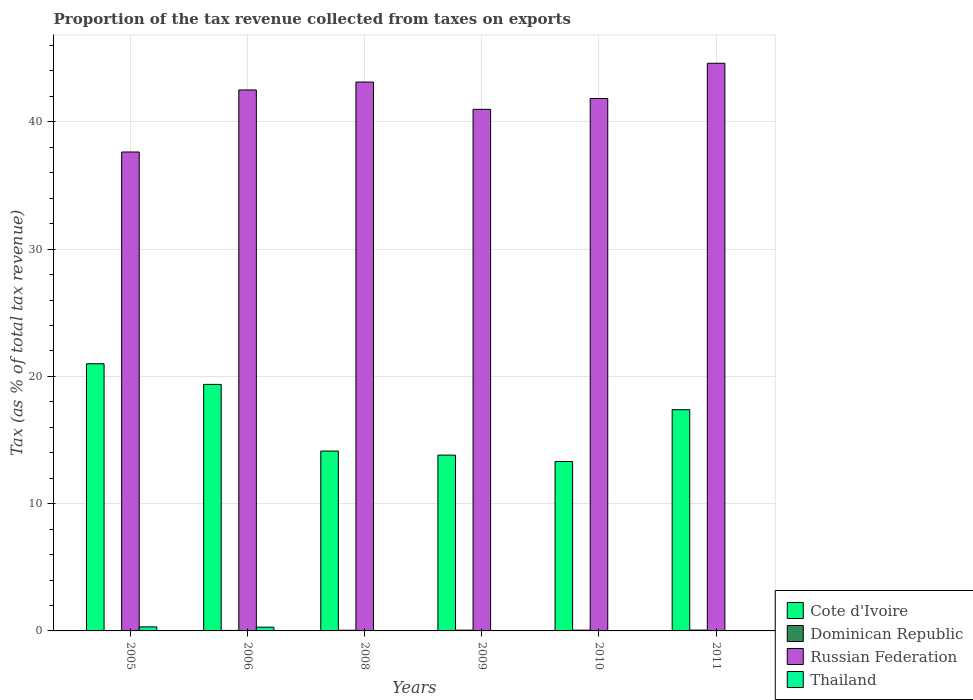How many groups of bars are there?
Ensure brevity in your answer.  6. How many bars are there on the 6th tick from the right?
Make the answer very short. 4. In how many cases, is the number of bars for a given year not equal to the number of legend labels?
Your answer should be compact. 0. What is the proportion of the tax revenue collected in Cote d'Ivoire in 2010?
Keep it short and to the point. 13.31. Across all years, what is the maximum proportion of the tax revenue collected in Thailand?
Ensure brevity in your answer.  0.32. Across all years, what is the minimum proportion of the tax revenue collected in Russian Federation?
Your response must be concise. 37.63. In which year was the proportion of the tax revenue collected in Dominican Republic minimum?
Your answer should be compact. 2005. What is the total proportion of the tax revenue collected in Dominican Republic in the graph?
Keep it short and to the point. 0.29. What is the difference between the proportion of the tax revenue collected in Russian Federation in 2005 and that in 2008?
Make the answer very short. -5.5. What is the difference between the proportion of the tax revenue collected in Dominican Republic in 2011 and the proportion of the tax revenue collected in Russian Federation in 2005?
Offer a terse response. -37.57. What is the average proportion of the tax revenue collected in Dominican Republic per year?
Keep it short and to the point. 0.05. In the year 2008, what is the difference between the proportion of the tax revenue collected in Cote d'Ivoire and proportion of the tax revenue collected in Russian Federation?
Give a very brief answer. -29. What is the ratio of the proportion of the tax revenue collected in Thailand in 2010 to that in 2011?
Your answer should be very brief. 0.8. Is the proportion of the tax revenue collected in Russian Federation in 2008 less than that in 2009?
Offer a terse response. No. Is the difference between the proportion of the tax revenue collected in Cote d'Ivoire in 2005 and 2010 greater than the difference between the proportion of the tax revenue collected in Russian Federation in 2005 and 2010?
Give a very brief answer. Yes. What is the difference between the highest and the second highest proportion of the tax revenue collected in Dominican Republic?
Ensure brevity in your answer.  0.01. What is the difference between the highest and the lowest proportion of the tax revenue collected in Russian Federation?
Make the answer very short. 6.97. Is it the case that in every year, the sum of the proportion of the tax revenue collected in Dominican Republic and proportion of the tax revenue collected in Cote d'Ivoire is greater than the sum of proportion of the tax revenue collected in Russian Federation and proportion of the tax revenue collected in Thailand?
Provide a succinct answer. No. What does the 3rd bar from the left in 2010 represents?
Ensure brevity in your answer.  Russian Federation. What does the 4th bar from the right in 2010 represents?
Offer a terse response. Cote d'Ivoire. Are all the bars in the graph horizontal?
Provide a succinct answer. No. Are the values on the major ticks of Y-axis written in scientific E-notation?
Your answer should be very brief. No. How many legend labels are there?
Offer a very short reply. 4. What is the title of the graph?
Keep it short and to the point. Proportion of the tax revenue collected from taxes on exports. Does "Bulgaria" appear as one of the legend labels in the graph?
Ensure brevity in your answer.  No. What is the label or title of the Y-axis?
Provide a short and direct response. Tax (as % of total tax revenue). What is the Tax (as % of total tax revenue) in Cote d'Ivoire in 2005?
Your answer should be compact. 21. What is the Tax (as % of total tax revenue) in Dominican Republic in 2005?
Offer a terse response. 0.01. What is the Tax (as % of total tax revenue) of Russian Federation in 2005?
Provide a short and direct response. 37.63. What is the Tax (as % of total tax revenue) in Thailand in 2005?
Provide a short and direct response. 0.32. What is the Tax (as % of total tax revenue) in Cote d'Ivoire in 2006?
Keep it short and to the point. 19.37. What is the Tax (as % of total tax revenue) in Dominican Republic in 2006?
Offer a terse response. 0.04. What is the Tax (as % of total tax revenue) in Russian Federation in 2006?
Offer a terse response. 42.51. What is the Tax (as % of total tax revenue) of Thailand in 2006?
Your answer should be very brief. 0.3. What is the Tax (as % of total tax revenue) of Cote d'Ivoire in 2008?
Make the answer very short. 14.13. What is the Tax (as % of total tax revenue) in Dominican Republic in 2008?
Keep it short and to the point. 0.05. What is the Tax (as % of total tax revenue) in Russian Federation in 2008?
Offer a very short reply. 43.13. What is the Tax (as % of total tax revenue) of Thailand in 2008?
Your answer should be very brief. 0.03. What is the Tax (as % of total tax revenue) in Cote d'Ivoire in 2009?
Give a very brief answer. 13.81. What is the Tax (as % of total tax revenue) of Dominican Republic in 2009?
Offer a very short reply. 0.06. What is the Tax (as % of total tax revenue) in Russian Federation in 2009?
Offer a very short reply. 40.99. What is the Tax (as % of total tax revenue) of Thailand in 2009?
Your answer should be compact. 0.03. What is the Tax (as % of total tax revenue) of Cote d'Ivoire in 2010?
Offer a terse response. 13.31. What is the Tax (as % of total tax revenue) of Dominican Republic in 2010?
Ensure brevity in your answer.  0.06. What is the Tax (as % of total tax revenue) of Russian Federation in 2010?
Your answer should be compact. 41.84. What is the Tax (as % of total tax revenue) in Thailand in 2010?
Your answer should be compact. 0.01. What is the Tax (as % of total tax revenue) of Cote d'Ivoire in 2011?
Your answer should be compact. 17.38. What is the Tax (as % of total tax revenue) of Dominican Republic in 2011?
Your answer should be very brief. 0.07. What is the Tax (as % of total tax revenue) in Russian Federation in 2011?
Offer a terse response. 44.61. What is the Tax (as % of total tax revenue) in Thailand in 2011?
Give a very brief answer. 0.01. Across all years, what is the maximum Tax (as % of total tax revenue) of Cote d'Ivoire?
Keep it short and to the point. 21. Across all years, what is the maximum Tax (as % of total tax revenue) in Dominican Republic?
Provide a succinct answer. 0.07. Across all years, what is the maximum Tax (as % of total tax revenue) of Russian Federation?
Offer a terse response. 44.61. Across all years, what is the maximum Tax (as % of total tax revenue) in Thailand?
Offer a terse response. 0.32. Across all years, what is the minimum Tax (as % of total tax revenue) in Cote d'Ivoire?
Keep it short and to the point. 13.31. Across all years, what is the minimum Tax (as % of total tax revenue) of Dominican Republic?
Give a very brief answer. 0.01. Across all years, what is the minimum Tax (as % of total tax revenue) of Russian Federation?
Keep it short and to the point. 37.63. Across all years, what is the minimum Tax (as % of total tax revenue) in Thailand?
Provide a short and direct response. 0.01. What is the total Tax (as % of total tax revenue) in Cote d'Ivoire in the graph?
Give a very brief answer. 99.01. What is the total Tax (as % of total tax revenue) in Dominican Republic in the graph?
Your answer should be compact. 0.29. What is the total Tax (as % of total tax revenue) of Russian Federation in the graph?
Offer a terse response. 250.71. What is the total Tax (as % of total tax revenue) of Thailand in the graph?
Provide a succinct answer. 0.7. What is the difference between the Tax (as % of total tax revenue) in Cote d'Ivoire in 2005 and that in 2006?
Your answer should be very brief. 1.62. What is the difference between the Tax (as % of total tax revenue) in Dominican Republic in 2005 and that in 2006?
Offer a very short reply. -0.03. What is the difference between the Tax (as % of total tax revenue) in Russian Federation in 2005 and that in 2006?
Your response must be concise. -4.87. What is the difference between the Tax (as % of total tax revenue) of Thailand in 2005 and that in 2006?
Your response must be concise. 0.02. What is the difference between the Tax (as % of total tax revenue) in Cote d'Ivoire in 2005 and that in 2008?
Keep it short and to the point. 6.86. What is the difference between the Tax (as % of total tax revenue) in Dominican Republic in 2005 and that in 2008?
Offer a very short reply. -0.05. What is the difference between the Tax (as % of total tax revenue) in Russian Federation in 2005 and that in 2008?
Provide a succinct answer. -5.5. What is the difference between the Tax (as % of total tax revenue) of Thailand in 2005 and that in 2008?
Your answer should be compact. 0.28. What is the difference between the Tax (as % of total tax revenue) of Cote d'Ivoire in 2005 and that in 2009?
Provide a short and direct response. 7.18. What is the difference between the Tax (as % of total tax revenue) in Dominican Republic in 2005 and that in 2009?
Provide a succinct answer. -0.05. What is the difference between the Tax (as % of total tax revenue) in Russian Federation in 2005 and that in 2009?
Offer a terse response. -3.35. What is the difference between the Tax (as % of total tax revenue) in Thailand in 2005 and that in 2009?
Your response must be concise. 0.29. What is the difference between the Tax (as % of total tax revenue) of Cote d'Ivoire in 2005 and that in 2010?
Give a very brief answer. 7.69. What is the difference between the Tax (as % of total tax revenue) in Dominican Republic in 2005 and that in 2010?
Provide a succinct answer. -0.05. What is the difference between the Tax (as % of total tax revenue) in Russian Federation in 2005 and that in 2010?
Provide a succinct answer. -4.2. What is the difference between the Tax (as % of total tax revenue) in Thailand in 2005 and that in 2010?
Keep it short and to the point. 0.31. What is the difference between the Tax (as % of total tax revenue) in Cote d'Ivoire in 2005 and that in 2011?
Your answer should be very brief. 3.61. What is the difference between the Tax (as % of total tax revenue) in Dominican Republic in 2005 and that in 2011?
Provide a short and direct response. -0.06. What is the difference between the Tax (as % of total tax revenue) in Russian Federation in 2005 and that in 2011?
Keep it short and to the point. -6.97. What is the difference between the Tax (as % of total tax revenue) in Thailand in 2005 and that in 2011?
Your answer should be very brief. 0.3. What is the difference between the Tax (as % of total tax revenue) in Cote d'Ivoire in 2006 and that in 2008?
Offer a terse response. 5.24. What is the difference between the Tax (as % of total tax revenue) in Dominican Republic in 2006 and that in 2008?
Your answer should be very brief. -0.02. What is the difference between the Tax (as % of total tax revenue) in Russian Federation in 2006 and that in 2008?
Your response must be concise. -0.62. What is the difference between the Tax (as % of total tax revenue) of Thailand in 2006 and that in 2008?
Offer a very short reply. 0.26. What is the difference between the Tax (as % of total tax revenue) in Cote d'Ivoire in 2006 and that in 2009?
Your response must be concise. 5.56. What is the difference between the Tax (as % of total tax revenue) in Dominican Republic in 2006 and that in 2009?
Your answer should be compact. -0.02. What is the difference between the Tax (as % of total tax revenue) in Russian Federation in 2006 and that in 2009?
Make the answer very short. 1.52. What is the difference between the Tax (as % of total tax revenue) in Thailand in 2006 and that in 2009?
Make the answer very short. 0.27. What is the difference between the Tax (as % of total tax revenue) in Cote d'Ivoire in 2006 and that in 2010?
Provide a short and direct response. 6.06. What is the difference between the Tax (as % of total tax revenue) in Dominican Republic in 2006 and that in 2010?
Your answer should be compact. -0.02. What is the difference between the Tax (as % of total tax revenue) of Russian Federation in 2006 and that in 2010?
Your answer should be compact. 0.67. What is the difference between the Tax (as % of total tax revenue) of Thailand in 2006 and that in 2010?
Offer a very short reply. 0.28. What is the difference between the Tax (as % of total tax revenue) of Cote d'Ivoire in 2006 and that in 2011?
Your answer should be compact. 1.99. What is the difference between the Tax (as % of total tax revenue) of Dominican Republic in 2006 and that in 2011?
Provide a short and direct response. -0.03. What is the difference between the Tax (as % of total tax revenue) in Russian Federation in 2006 and that in 2011?
Keep it short and to the point. -2.1. What is the difference between the Tax (as % of total tax revenue) in Thailand in 2006 and that in 2011?
Make the answer very short. 0.28. What is the difference between the Tax (as % of total tax revenue) of Cote d'Ivoire in 2008 and that in 2009?
Your response must be concise. 0.32. What is the difference between the Tax (as % of total tax revenue) in Dominican Republic in 2008 and that in 2009?
Give a very brief answer. -0.01. What is the difference between the Tax (as % of total tax revenue) of Russian Federation in 2008 and that in 2009?
Make the answer very short. 2.15. What is the difference between the Tax (as % of total tax revenue) of Thailand in 2008 and that in 2009?
Ensure brevity in your answer.  0. What is the difference between the Tax (as % of total tax revenue) of Cote d'Ivoire in 2008 and that in 2010?
Provide a short and direct response. 0.82. What is the difference between the Tax (as % of total tax revenue) of Dominican Republic in 2008 and that in 2010?
Offer a very short reply. -0.01. What is the difference between the Tax (as % of total tax revenue) in Russian Federation in 2008 and that in 2010?
Your answer should be compact. 1.3. What is the difference between the Tax (as % of total tax revenue) in Thailand in 2008 and that in 2010?
Make the answer very short. 0.02. What is the difference between the Tax (as % of total tax revenue) in Cote d'Ivoire in 2008 and that in 2011?
Give a very brief answer. -3.25. What is the difference between the Tax (as % of total tax revenue) of Dominican Republic in 2008 and that in 2011?
Offer a very short reply. -0.01. What is the difference between the Tax (as % of total tax revenue) of Russian Federation in 2008 and that in 2011?
Provide a short and direct response. -1.48. What is the difference between the Tax (as % of total tax revenue) of Thailand in 2008 and that in 2011?
Offer a very short reply. 0.02. What is the difference between the Tax (as % of total tax revenue) of Cote d'Ivoire in 2009 and that in 2010?
Make the answer very short. 0.5. What is the difference between the Tax (as % of total tax revenue) in Dominican Republic in 2009 and that in 2010?
Provide a short and direct response. -0. What is the difference between the Tax (as % of total tax revenue) of Russian Federation in 2009 and that in 2010?
Your answer should be compact. -0.85. What is the difference between the Tax (as % of total tax revenue) of Thailand in 2009 and that in 2010?
Give a very brief answer. 0.02. What is the difference between the Tax (as % of total tax revenue) in Cote d'Ivoire in 2009 and that in 2011?
Make the answer very short. -3.57. What is the difference between the Tax (as % of total tax revenue) of Dominican Republic in 2009 and that in 2011?
Offer a very short reply. -0.01. What is the difference between the Tax (as % of total tax revenue) in Russian Federation in 2009 and that in 2011?
Make the answer very short. -3.62. What is the difference between the Tax (as % of total tax revenue) of Thailand in 2009 and that in 2011?
Your answer should be compact. 0.02. What is the difference between the Tax (as % of total tax revenue) of Cote d'Ivoire in 2010 and that in 2011?
Provide a succinct answer. -4.07. What is the difference between the Tax (as % of total tax revenue) of Dominican Republic in 2010 and that in 2011?
Ensure brevity in your answer.  -0.01. What is the difference between the Tax (as % of total tax revenue) in Russian Federation in 2010 and that in 2011?
Make the answer very short. -2.77. What is the difference between the Tax (as % of total tax revenue) of Thailand in 2010 and that in 2011?
Make the answer very short. -0. What is the difference between the Tax (as % of total tax revenue) in Cote d'Ivoire in 2005 and the Tax (as % of total tax revenue) in Dominican Republic in 2006?
Your answer should be compact. 20.96. What is the difference between the Tax (as % of total tax revenue) in Cote d'Ivoire in 2005 and the Tax (as % of total tax revenue) in Russian Federation in 2006?
Your answer should be compact. -21.51. What is the difference between the Tax (as % of total tax revenue) of Cote d'Ivoire in 2005 and the Tax (as % of total tax revenue) of Thailand in 2006?
Keep it short and to the point. 20.7. What is the difference between the Tax (as % of total tax revenue) in Dominican Republic in 2005 and the Tax (as % of total tax revenue) in Russian Federation in 2006?
Offer a very short reply. -42.5. What is the difference between the Tax (as % of total tax revenue) of Dominican Republic in 2005 and the Tax (as % of total tax revenue) of Thailand in 2006?
Offer a very short reply. -0.29. What is the difference between the Tax (as % of total tax revenue) of Russian Federation in 2005 and the Tax (as % of total tax revenue) of Thailand in 2006?
Your response must be concise. 37.34. What is the difference between the Tax (as % of total tax revenue) of Cote d'Ivoire in 2005 and the Tax (as % of total tax revenue) of Dominican Republic in 2008?
Make the answer very short. 20.94. What is the difference between the Tax (as % of total tax revenue) of Cote d'Ivoire in 2005 and the Tax (as % of total tax revenue) of Russian Federation in 2008?
Provide a short and direct response. -22.14. What is the difference between the Tax (as % of total tax revenue) of Cote d'Ivoire in 2005 and the Tax (as % of total tax revenue) of Thailand in 2008?
Offer a terse response. 20.96. What is the difference between the Tax (as % of total tax revenue) in Dominican Republic in 2005 and the Tax (as % of total tax revenue) in Russian Federation in 2008?
Ensure brevity in your answer.  -43.12. What is the difference between the Tax (as % of total tax revenue) in Dominican Republic in 2005 and the Tax (as % of total tax revenue) in Thailand in 2008?
Provide a succinct answer. -0.02. What is the difference between the Tax (as % of total tax revenue) of Russian Federation in 2005 and the Tax (as % of total tax revenue) of Thailand in 2008?
Ensure brevity in your answer.  37.6. What is the difference between the Tax (as % of total tax revenue) of Cote d'Ivoire in 2005 and the Tax (as % of total tax revenue) of Dominican Republic in 2009?
Provide a short and direct response. 20.94. What is the difference between the Tax (as % of total tax revenue) in Cote d'Ivoire in 2005 and the Tax (as % of total tax revenue) in Russian Federation in 2009?
Offer a terse response. -19.99. What is the difference between the Tax (as % of total tax revenue) in Cote d'Ivoire in 2005 and the Tax (as % of total tax revenue) in Thailand in 2009?
Your answer should be very brief. 20.97. What is the difference between the Tax (as % of total tax revenue) in Dominican Republic in 2005 and the Tax (as % of total tax revenue) in Russian Federation in 2009?
Your response must be concise. -40.98. What is the difference between the Tax (as % of total tax revenue) in Dominican Republic in 2005 and the Tax (as % of total tax revenue) in Thailand in 2009?
Keep it short and to the point. -0.02. What is the difference between the Tax (as % of total tax revenue) in Russian Federation in 2005 and the Tax (as % of total tax revenue) in Thailand in 2009?
Offer a very short reply. 37.61. What is the difference between the Tax (as % of total tax revenue) of Cote d'Ivoire in 2005 and the Tax (as % of total tax revenue) of Dominican Republic in 2010?
Ensure brevity in your answer.  20.94. What is the difference between the Tax (as % of total tax revenue) of Cote d'Ivoire in 2005 and the Tax (as % of total tax revenue) of Russian Federation in 2010?
Keep it short and to the point. -20.84. What is the difference between the Tax (as % of total tax revenue) of Cote d'Ivoire in 2005 and the Tax (as % of total tax revenue) of Thailand in 2010?
Keep it short and to the point. 20.99. What is the difference between the Tax (as % of total tax revenue) in Dominican Republic in 2005 and the Tax (as % of total tax revenue) in Russian Federation in 2010?
Provide a succinct answer. -41.83. What is the difference between the Tax (as % of total tax revenue) of Dominican Republic in 2005 and the Tax (as % of total tax revenue) of Thailand in 2010?
Keep it short and to the point. -0. What is the difference between the Tax (as % of total tax revenue) in Russian Federation in 2005 and the Tax (as % of total tax revenue) in Thailand in 2010?
Give a very brief answer. 37.62. What is the difference between the Tax (as % of total tax revenue) in Cote d'Ivoire in 2005 and the Tax (as % of total tax revenue) in Dominican Republic in 2011?
Your answer should be very brief. 20.93. What is the difference between the Tax (as % of total tax revenue) of Cote d'Ivoire in 2005 and the Tax (as % of total tax revenue) of Russian Federation in 2011?
Give a very brief answer. -23.61. What is the difference between the Tax (as % of total tax revenue) of Cote d'Ivoire in 2005 and the Tax (as % of total tax revenue) of Thailand in 2011?
Offer a terse response. 20.98. What is the difference between the Tax (as % of total tax revenue) of Dominican Republic in 2005 and the Tax (as % of total tax revenue) of Russian Federation in 2011?
Provide a succinct answer. -44.6. What is the difference between the Tax (as % of total tax revenue) of Dominican Republic in 2005 and the Tax (as % of total tax revenue) of Thailand in 2011?
Give a very brief answer. -0. What is the difference between the Tax (as % of total tax revenue) in Russian Federation in 2005 and the Tax (as % of total tax revenue) in Thailand in 2011?
Offer a very short reply. 37.62. What is the difference between the Tax (as % of total tax revenue) of Cote d'Ivoire in 2006 and the Tax (as % of total tax revenue) of Dominican Republic in 2008?
Offer a very short reply. 19.32. What is the difference between the Tax (as % of total tax revenue) of Cote d'Ivoire in 2006 and the Tax (as % of total tax revenue) of Russian Federation in 2008?
Provide a succinct answer. -23.76. What is the difference between the Tax (as % of total tax revenue) of Cote d'Ivoire in 2006 and the Tax (as % of total tax revenue) of Thailand in 2008?
Make the answer very short. 19.34. What is the difference between the Tax (as % of total tax revenue) of Dominican Republic in 2006 and the Tax (as % of total tax revenue) of Russian Federation in 2008?
Your answer should be compact. -43.09. What is the difference between the Tax (as % of total tax revenue) in Dominican Republic in 2006 and the Tax (as % of total tax revenue) in Thailand in 2008?
Offer a very short reply. 0.01. What is the difference between the Tax (as % of total tax revenue) of Russian Federation in 2006 and the Tax (as % of total tax revenue) of Thailand in 2008?
Make the answer very short. 42.48. What is the difference between the Tax (as % of total tax revenue) of Cote d'Ivoire in 2006 and the Tax (as % of total tax revenue) of Dominican Republic in 2009?
Make the answer very short. 19.31. What is the difference between the Tax (as % of total tax revenue) of Cote d'Ivoire in 2006 and the Tax (as % of total tax revenue) of Russian Federation in 2009?
Offer a very short reply. -21.61. What is the difference between the Tax (as % of total tax revenue) of Cote d'Ivoire in 2006 and the Tax (as % of total tax revenue) of Thailand in 2009?
Provide a short and direct response. 19.34. What is the difference between the Tax (as % of total tax revenue) of Dominican Republic in 2006 and the Tax (as % of total tax revenue) of Russian Federation in 2009?
Provide a short and direct response. -40.95. What is the difference between the Tax (as % of total tax revenue) of Dominican Republic in 2006 and the Tax (as % of total tax revenue) of Thailand in 2009?
Provide a short and direct response. 0.01. What is the difference between the Tax (as % of total tax revenue) of Russian Federation in 2006 and the Tax (as % of total tax revenue) of Thailand in 2009?
Make the answer very short. 42.48. What is the difference between the Tax (as % of total tax revenue) in Cote d'Ivoire in 2006 and the Tax (as % of total tax revenue) in Dominican Republic in 2010?
Your answer should be compact. 19.31. What is the difference between the Tax (as % of total tax revenue) in Cote d'Ivoire in 2006 and the Tax (as % of total tax revenue) in Russian Federation in 2010?
Provide a short and direct response. -22.46. What is the difference between the Tax (as % of total tax revenue) in Cote d'Ivoire in 2006 and the Tax (as % of total tax revenue) in Thailand in 2010?
Your response must be concise. 19.36. What is the difference between the Tax (as % of total tax revenue) in Dominican Republic in 2006 and the Tax (as % of total tax revenue) in Russian Federation in 2010?
Your response must be concise. -41.8. What is the difference between the Tax (as % of total tax revenue) of Dominican Republic in 2006 and the Tax (as % of total tax revenue) of Thailand in 2010?
Your answer should be very brief. 0.03. What is the difference between the Tax (as % of total tax revenue) of Russian Federation in 2006 and the Tax (as % of total tax revenue) of Thailand in 2010?
Offer a terse response. 42.5. What is the difference between the Tax (as % of total tax revenue) of Cote d'Ivoire in 2006 and the Tax (as % of total tax revenue) of Dominican Republic in 2011?
Give a very brief answer. 19.31. What is the difference between the Tax (as % of total tax revenue) in Cote d'Ivoire in 2006 and the Tax (as % of total tax revenue) in Russian Federation in 2011?
Provide a succinct answer. -25.24. What is the difference between the Tax (as % of total tax revenue) in Cote d'Ivoire in 2006 and the Tax (as % of total tax revenue) in Thailand in 2011?
Your answer should be compact. 19.36. What is the difference between the Tax (as % of total tax revenue) in Dominican Republic in 2006 and the Tax (as % of total tax revenue) in Russian Federation in 2011?
Keep it short and to the point. -44.57. What is the difference between the Tax (as % of total tax revenue) of Dominican Republic in 2006 and the Tax (as % of total tax revenue) of Thailand in 2011?
Keep it short and to the point. 0.03. What is the difference between the Tax (as % of total tax revenue) in Russian Federation in 2006 and the Tax (as % of total tax revenue) in Thailand in 2011?
Your response must be concise. 42.5. What is the difference between the Tax (as % of total tax revenue) in Cote d'Ivoire in 2008 and the Tax (as % of total tax revenue) in Dominican Republic in 2009?
Give a very brief answer. 14.07. What is the difference between the Tax (as % of total tax revenue) in Cote d'Ivoire in 2008 and the Tax (as % of total tax revenue) in Russian Federation in 2009?
Give a very brief answer. -26.85. What is the difference between the Tax (as % of total tax revenue) of Cote d'Ivoire in 2008 and the Tax (as % of total tax revenue) of Thailand in 2009?
Provide a succinct answer. 14.1. What is the difference between the Tax (as % of total tax revenue) of Dominican Republic in 2008 and the Tax (as % of total tax revenue) of Russian Federation in 2009?
Your answer should be very brief. -40.93. What is the difference between the Tax (as % of total tax revenue) in Dominican Republic in 2008 and the Tax (as % of total tax revenue) in Thailand in 2009?
Offer a terse response. 0.03. What is the difference between the Tax (as % of total tax revenue) in Russian Federation in 2008 and the Tax (as % of total tax revenue) in Thailand in 2009?
Give a very brief answer. 43.1. What is the difference between the Tax (as % of total tax revenue) in Cote d'Ivoire in 2008 and the Tax (as % of total tax revenue) in Dominican Republic in 2010?
Provide a succinct answer. 14.07. What is the difference between the Tax (as % of total tax revenue) in Cote d'Ivoire in 2008 and the Tax (as % of total tax revenue) in Russian Federation in 2010?
Ensure brevity in your answer.  -27.7. What is the difference between the Tax (as % of total tax revenue) in Cote d'Ivoire in 2008 and the Tax (as % of total tax revenue) in Thailand in 2010?
Your response must be concise. 14.12. What is the difference between the Tax (as % of total tax revenue) of Dominican Republic in 2008 and the Tax (as % of total tax revenue) of Russian Federation in 2010?
Make the answer very short. -41.78. What is the difference between the Tax (as % of total tax revenue) in Dominican Republic in 2008 and the Tax (as % of total tax revenue) in Thailand in 2010?
Your answer should be very brief. 0.04. What is the difference between the Tax (as % of total tax revenue) in Russian Federation in 2008 and the Tax (as % of total tax revenue) in Thailand in 2010?
Ensure brevity in your answer.  43.12. What is the difference between the Tax (as % of total tax revenue) in Cote d'Ivoire in 2008 and the Tax (as % of total tax revenue) in Dominican Republic in 2011?
Offer a terse response. 14.07. What is the difference between the Tax (as % of total tax revenue) of Cote d'Ivoire in 2008 and the Tax (as % of total tax revenue) of Russian Federation in 2011?
Give a very brief answer. -30.47. What is the difference between the Tax (as % of total tax revenue) of Cote d'Ivoire in 2008 and the Tax (as % of total tax revenue) of Thailand in 2011?
Offer a terse response. 14.12. What is the difference between the Tax (as % of total tax revenue) in Dominican Republic in 2008 and the Tax (as % of total tax revenue) in Russian Federation in 2011?
Offer a terse response. -44.55. What is the difference between the Tax (as % of total tax revenue) of Dominican Republic in 2008 and the Tax (as % of total tax revenue) of Thailand in 2011?
Make the answer very short. 0.04. What is the difference between the Tax (as % of total tax revenue) of Russian Federation in 2008 and the Tax (as % of total tax revenue) of Thailand in 2011?
Provide a short and direct response. 43.12. What is the difference between the Tax (as % of total tax revenue) in Cote d'Ivoire in 2009 and the Tax (as % of total tax revenue) in Dominican Republic in 2010?
Keep it short and to the point. 13.75. What is the difference between the Tax (as % of total tax revenue) in Cote d'Ivoire in 2009 and the Tax (as % of total tax revenue) in Russian Federation in 2010?
Offer a terse response. -28.02. What is the difference between the Tax (as % of total tax revenue) in Cote d'Ivoire in 2009 and the Tax (as % of total tax revenue) in Thailand in 2010?
Offer a very short reply. 13.8. What is the difference between the Tax (as % of total tax revenue) in Dominican Republic in 2009 and the Tax (as % of total tax revenue) in Russian Federation in 2010?
Your response must be concise. -41.78. What is the difference between the Tax (as % of total tax revenue) of Dominican Republic in 2009 and the Tax (as % of total tax revenue) of Thailand in 2010?
Your answer should be compact. 0.05. What is the difference between the Tax (as % of total tax revenue) of Russian Federation in 2009 and the Tax (as % of total tax revenue) of Thailand in 2010?
Keep it short and to the point. 40.98. What is the difference between the Tax (as % of total tax revenue) in Cote d'Ivoire in 2009 and the Tax (as % of total tax revenue) in Dominican Republic in 2011?
Keep it short and to the point. 13.75. What is the difference between the Tax (as % of total tax revenue) of Cote d'Ivoire in 2009 and the Tax (as % of total tax revenue) of Russian Federation in 2011?
Make the answer very short. -30.79. What is the difference between the Tax (as % of total tax revenue) of Cote d'Ivoire in 2009 and the Tax (as % of total tax revenue) of Thailand in 2011?
Provide a short and direct response. 13.8. What is the difference between the Tax (as % of total tax revenue) in Dominican Republic in 2009 and the Tax (as % of total tax revenue) in Russian Federation in 2011?
Give a very brief answer. -44.55. What is the difference between the Tax (as % of total tax revenue) in Dominican Republic in 2009 and the Tax (as % of total tax revenue) in Thailand in 2011?
Provide a short and direct response. 0.05. What is the difference between the Tax (as % of total tax revenue) of Russian Federation in 2009 and the Tax (as % of total tax revenue) of Thailand in 2011?
Provide a succinct answer. 40.97. What is the difference between the Tax (as % of total tax revenue) of Cote d'Ivoire in 2010 and the Tax (as % of total tax revenue) of Dominican Republic in 2011?
Your answer should be very brief. 13.24. What is the difference between the Tax (as % of total tax revenue) of Cote d'Ivoire in 2010 and the Tax (as % of total tax revenue) of Russian Federation in 2011?
Offer a terse response. -31.3. What is the difference between the Tax (as % of total tax revenue) in Cote d'Ivoire in 2010 and the Tax (as % of total tax revenue) in Thailand in 2011?
Your answer should be very brief. 13.3. What is the difference between the Tax (as % of total tax revenue) in Dominican Republic in 2010 and the Tax (as % of total tax revenue) in Russian Federation in 2011?
Ensure brevity in your answer.  -44.55. What is the difference between the Tax (as % of total tax revenue) in Dominican Republic in 2010 and the Tax (as % of total tax revenue) in Thailand in 2011?
Provide a succinct answer. 0.05. What is the difference between the Tax (as % of total tax revenue) in Russian Federation in 2010 and the Tax (as % of total tax revenue) in Thailand in 2011?
Give a very brief answer. 41.82. What is the average Tax (as % of total tax revenue) in Cote d'Ivoire per year?
Provide a succinct answer. 16.5. What is the average Tax (as % of total tax revenue) in Dominican Republic per year?
Give a very brief answer. 0.05. What is the average Tax (as % of total tax revenue) in Russian Federation per year?
Give a very brief answer. 41.78. What is the average Tax (as % of total tax revenue) of Thailand per year?
Provide a succinct answer. 0.12. In the year 2005, what is the difference between the Tax (as % of total tax revenue) of Cote d'Ivoire and Tax (as % of total tax revenue) of Dominican Republic?
Your answer should be compact. 20.99. In the year 2005, what is the difference between the Tax (as % of total tax revenue) of Cote d'Ivoire and Tax (as % of total tax revenue) of Russian Federation?
Provide a short and direct response. -16.64. In the year 2005, what is the difference between the Tax (as % of total tax revenue) in Cote d'Ivoire and Tax (as % of total tax revenue) in Thailand?
Your answer should be very brief. 20.68. In the year 2005, what is the difference between the Tax (as % of total tax revenue) of Dominican Republic and Tax (as % of total tax revenue) of Russian Federation?
Ensure brevity in your answer.  -37.63. In the year 2005, what is the difference between the Tax (as % of total tax revenue) of Dominican Republic and Tax (as % of total tax revenue) of Thailand?
Make the answer very short. -0.31. In the year 2005, what is the difference between the Tax (as % of total tax revenue) of Russian Federation and Tax (as % of total tax revenue) of Thailand?
Give a very brief answer. 37.32. In the year 2006, what is the difference between the Tax (as % of total tax revenue) of Cote d'Ivoire and Tax (as % of total tax revenue) of Dominican Republic?
Keep it short and to the point. 19.33. In the year 2006, what is the difference between the Tax (as % of total tax revenue) of Cote d'Ivoire and Tax (as % of total tax revenue) of Russian Federation?
Provide a short and direct response. -23.14. In the year 2006, what is the difference between the Tax (as % of total tax revenue) of Cote d'Ivoire and Tax (as % of total tax revenue) of Thailand?
Give a very brief answer. 19.08. In the year 2006, what is the difference between the Tax (as % of total tax revenue) of Dominican Republic and Tax (as % of total tax revenue) of Russian Federation?
Keep it short and to the point. -42.47. In the year 2006, what is the difference between the Tax (as % of total tax revenue) of Dominican Republic and Tax (as % of total tax revenue) of Thailand?
Your answer should be compact. -0.26. In the year 2006, what is the difference between the Tax (as % of total tax revenue) of Russian Federation and Tax (as % of total tax revenue) of Thailand?
Offer a terse response. 42.21. In the year 2008, what is the difference between the Tax (as % of total tax revenue) in Cote d'Ivoire and Tax (as % of total tax revenue) in Dominican Republic?
Give a very brief answer. 14.08. In the year 2008, what is the difference between the Tax (as % of total tax revenue) of Cote d'Ivoire and Tax (as % of total tax revenue) of Russian Federation?
Make the answer very short. -29. In the year 2008, what is the difference between the Tax (as % of total tax revenue) in Cote d'Ivoire and Tax (as % of total tax revenue) in Thailand?
Your response must be concise. 14.1. In the year 2008, what is the difference between the Tax (as % of total tax revenue) of Dominican Republic and Tax (as % of total tax revenue) of Russian Federation?
Your answer should be compact. -43.08. In the year 2008, what is the difference between the Tax (as % of total tax revenue) of Dominican Republic and Tax (as % of total tax revenue) of Thailand?
Make the answer very short. 0.02. In the year 2008, what is the difference between the Tax (as % of total tax revenue) of Russian Federation and Tax (as % of total tax revenue) of Thailand?
Keep it short and to the point. 43.1. In the year 2009, what is the difference between the Tax (as % of total tax revenue) of Cote d'Ivoire and Tax (as % of total tax revenue) of Dominican Republic?
Keep it short and to the point. 13.75. In the year 2009, what is the difference between the Tax (as % of total tax revenue) of Cote d'Ivoire and Tax (as % of total tax revenue) of Russian Federation?
Provide a short and direct response. -27.17. In the year 2009, what is the difference between the Tax (as % of total tax revenue) in Cote d'Ivoire and Tax (as % of total tax revenue) in Thailand?
Provide a short and direct response. 13.79. In the year 2009, what is the difference between the Tax (as % of total tax revenue) of Dominican Republic and Tax (as % of total tax revenue) of Russian Federation?
Your answer should be compact. -40.93. In the year 2009, what is the difference between the Tax (as % of total tax revenue) of Dominican Republic and Tax (as % of total tax revenue) of Thailand?
Your answer should be very brief. 0.03. In the year 2009, what is the difference between the Tax (as % of total tax revenue) of Russian Federation and Tax (as % of total tax revenue) of Thailand?
Your answer should be compact. 40.96. In the year 2010, what is the difference between the Tax (as % of total tax revenue) in Cote d'Ivoire and Tax (as % of total tax revenue) in Dominican Republic?
Your answer should be compact. 13.25. In the year 2010, what is the difference between the Tax (as % of total tax revenue) in Cote d'Ivoire and Tax (as % of total tax revenue) in Russian Federation?
Keep it short and to the point. -28.53. In the year 2010, what is the difference between the Tax (as % of total tax revenue) of Cote d'Ivoire and Tax (as % of total tax revenue) of Thailand?
Offer a very short reply. 13.3. In the year 2010, what is the difference between the Tax (as % of total tax revenue) of Dominican Republic and Tax (as % of total tax revenue) of Russian Federation?
Your response must be concise. -41.78. In the year 2010, what is the difference between the Tax (as % of total tax revenue) in Dominican Republic and Tax (as % of total tax revenue) in Thailand?
Provide a succinct answer. 0.05. In the year 2010, what is the difference between the Tax (as % of total tax revenue) in Russian Federation and Tax (as % of total tax revenue) in Thailand?
Your response must be concise. 41.83. In the year 2011, what is the difference between the Tax (as % of total tax revenue) in Cote d'Ivoire and Tax (as % of total tax revenue) in Dominican Republic?
Keep it short and to the point. 17.32. In the year 2011, what is the difference between the Tax (as % of total tax revenue) in Cote d'Ivoire and Tax (as % of total tax revenue) in Russian Federation?
Provide a succinct answer. -27.22. In the year 2011, what is the difference between the Tax (as % of total tax revenue) in Cote d'Ivoire and Tax (as % of total tax revenue) in Thailand?
Ensure brevity in your answer.  17.37. In the year 2011, what is the difference between the Tax (as % of total tax revenue) in Dominican Republic and Tax (as % of total tax revenue) in Russian Federation?
Ensure brevity in your answer.  -44.54. In the year 2011, what is the difference between the Tax (as % of total tax revenue) of Dominican Republic and Tax (as % of total tax revenue) of Thailand?
Your answer should be compact. 0.05. In the year 2011, what is the difference between the Tax (as % of total tax revenue) in Russian Federation and Tax (as % of total tax revenue) in Thailand?
Provide a succinct answer. 44.59. What is the ratio of the Tax (as % of total tax revenue) of Cote d'Ivoire in 2005 to that in 2006?
Your answer should be very brief. 1.08. What is the ratio of the Tax (as % of total tax revenue) of Dominican Republic in 2005 to that in 2006?
Your response must be concise. 0.23. What is the ratio of the Tax (as % of total tax revenue) in Russian Federation in 2005 to that in 2006?
Make the answer very short. 0.89. What is the ratio of the Tax (as % of total tax revenue) of Thailand in 2005 to that in 2006?
Ensure brevity in your answer.  1.08. What is the ratio of the Tax (as % of total tax revenue) of Cote d'Ivoire in 2005 to that in 2008?
Your answer should be very brief. 1.49. What is the ratio of the Tax (as % of total tax revenue) in Dominican Republic in 2005 to that in 2008?
Give a very brief answer. 0.17. What is the ratio of the Tax (as % of total tax revenue) in Russian Federation in 2005 to that in 2008?
Provide a short and direct response. 0.87. What is the ratio of the Tax (as % of total tax revenue) of Thailand in 2005 to that in 2008?
Provide a short and direct response. 9.49. What is the ratio of the Tax (as % of total tax revenue) of Cote d'Ivoire in 2005 to that in 2009?
Keep it short and to the point. 1.52. What is the ratio of the Tax (as % of total tax revenue) in Dominican Republic in 2005 to that in 2009?
Provide a succinct answer. 0.15. What is the ratio of the Tax (as % of total tax revenue) of Russian Federation in 2005 to that in 2009?
Offer a terse response. 0.92. What is the ratio of the Tax (as % of total tax revenue) in Thailand in 2005 to that in 2009?
Give a very brief answer. 10.89. What is the ratio of the Tax (as % of total tax revenue) of Cote d'Ivoire in 2005 to that in 2010?
Offer a very short reply. 1.58. What is the ratio of the Tax (as % of total tax revenue) of Dominican Republic in 2005 to that in 2010?
Make the answer very short. 0.15. What is the ratio of the Tax (as % of total tax revenue) in Russian Federation in 2005 to that in 2010?
Your response must be concise. 0.9. What is the ratio of the Tax (as % of total tax revenue) in Thailand in 2005 to that in 2010?
Ensure brevity in your answer.  30.63. What is the ratio of the Tax (as % of total tax revenue) of Cote d'Ivoire in 2005 to that in 2011?
Your answer should be very brief. 1.21. What is the ratio of the Tax (as % of total tax revenue) of Dominican Republic in 2005 to that in 2011?
Ensure brevity in your answer.  0.14. What is the ratio of the Tax (as % of total tax revenue) of Russian Federation in 2005 to that in 2011?
Give a very brief answer. 0.84. What is the ratio of the Tax (as % of total tax revenue) of Thailand in 2005 to that in 2011?
Offer a terse response. 24.62. What is the ratio of the Tax (as % of total tax revenue) of Cote d'Ivoire in 2006 to that in 2008?
Your answer should be very brief. 1.37. What is the ratio of the Tax (as % of total tax revenue) in Dominican Republic in 2006 to that in 2008?
Your answer should be compact. 0.72. What is the ratio of the Tax (as % of total tax revenue) of Russian Federation in 2006 to that in 2008?
Give a very brief answer. 0.99. What is the ratio of the Tax (as % of total tax revenue) of Thailand in 2006 to that in 2008?
Offer a terse response. 8.82. What is the ratio of the Tax (as % of total tax revenue) of Cote d'Ivoire in 2006 to that in 2009?
Your response must be concise. 1.4. What is the ratio of the Tax (as % of total tax revenue) in Dominican Republic in 2006 to that in 2009?
Provide a succinct answer. 0.65. What is the ratio of the Tax (as % of total tax revenue) of Russian Federation in 2006 to that in 2009?
Give a very brief answer. 1.04. What is the ratio of the Tax (as % of total tax revenue) in Thailand in 2006 to that in 2009?
Keep it short and to the point. 10.12. What is the ratio of the Tax (as % of total tax revenue) of Cote d'Ivoire in 2006 to that in 2010?
Provide a short and direct response. 1.46. What is the ratio of the Tax (as % of total tax revenue) in Dominican Republic in 2006 to that in 2010?
Provide a succinct answer. 0.65. What is the ratio of the Tax (as % of total tax revenue) of Russian Federation in 2006 to that in 2010?
Provide a succinct answer. 1.02. What is the ratio of the Tax (as % of total tax revenue) in Thailand in 2006 to that in 2010?
Ensure brevity in your answer.  28.46. What is the ratio of the Tax (as % of total tax revenue) in Cote d'Ivoire in 2006 to that in 2011?
Provide a short and direct response. 1.11. What is the ratio of the Tax (as % of total tax revenue) of Dominican Republic in 2006 to that in 2011?
Provide a succinct answer. 0.59. What is the ratio of the Tax (as % of total tax revenue) of Russian Federation in 2006 to that in 2011?
Your response must be concise. 0.95. What is the ratio of the Tax (as % of total tax revenue) in Thailand in 2006 to that in 2011?
Your answer should be compact. 22.87. What is the ratio of the Tax (as % of total tax revenue) of Cote d'Ivoire in 2008 to that in 2009?
Your answer should be very brief. 1.02. What is the ratio of the Tax (as % of total tax revenue) in Dominican Republic in 2008 to that in 2009?
Give a very brief answer. 0.91. What is the ratio of the Tax (as % of total tax revenue) in Russian Federation in 2008 to that in 2009?
Provide a succinct answer. 1.05. What is the ratio of the Tax (as % of total tax revenue) in Thailand in 2008 to that in 2009?
Ensure brevity in your answer.  1.15. What is the ratio of the Tax (as % of total tax revenue) of Cote d'Ivoire in 2008 to that in 2010?
Make the answer very short. 1.06. What is the ratio of the Tax (as % of total tax revenue) of Dominican Republic in 2008 to that in 2010?
Provide a succinct answer. 0.9. What is the ratio of the Tax (as % of total tax revenue) of Russian Federation in 2008 to that in 2010?
Your answer should be very brief. 1.03. What is the ratio of the Tax (as % of total tax revenue) in Thailand in 2008 to that in 2010?
Provide a short and direct response. 3.23. What is the ratio of the Tax (as % of total tax revenue) in Cote d'Ivoire in 2008 to that in 2011?
Your response must be concise. 0.81. What is the ratio of the Tax (as % of total tax revenue) of Dominican Republic in 2008 to that in 2011?
Give a very brief answer. 0.82. What is the ratio of the Tax (as % of total tax revenue) of Russian Federation in 2008 to that in 2011?
Your answer should be compact. 0.97. What is the ratio of the Tax (as % of total tax revenue) in Thailand in 2008 to that in 2011?
Your response must be concise. 2.59. What is the ratio of the Tax (as % of total tax revenue) in Cote d'Ivoire in 2009 to that in 2010?
Ensure brevity in your answer.  1.04. What is the ratio of the Tax (as % of total tax revenue) of Russian Federation in 2009 to that in 2010?
Provide a succinct answer. 0.98. What is the ratio of the Tax (as % of total tax revenue) of Thailand in 2009 to that in 2010?
Provide a succinct answer. 2.81. What is the ratio of the Tax (as % of total tax revenue) of Cote d'Ivoire in 2009 to that in 2011?
Offer a very short reply. 0.79. What is the ratio of the Tax (as % of total tax revenue) in Dominican Republic in 2009 to that in 2011?
Give a very brief answer. 0.9. What is the ratio of the Tax (as % of total tax revenue) of Russian Federation in 2009 to that in 2011?
Ensure brevity in your answer.  0.92. What is the ratio of the Tax (as % of total tax revenue) of Thailand in 2009 to that in 2011?
Your answer should be compact. 2.26. What is the ratio of the Tax (as % of total tax revenue) of Cote d'Ivoire in 2010 to that in 2011?
Provide a short and direct response. 0.77. What is the ratio of the Tax (as % of total tax revenue) in Dominican Republic in 2010 to that in 2011?
Your response must be concise. 0.91. What is the ratio of the Tax (as % of total tax revenue) in Russian Federation in 2010 to that in 2011?
Offer a terse response. 0.94. What is the ratio of the Tax (as % of total tax revenue) in Thailand in 2010 to that in 2011?
Give a very brief answer. 0.8. What is the difference between the highest and the second highest Tax (as % of total tax revenue) in Cote d'Ivoire?
Your answer should be compact. 1.62. What is the difference between the highest and the second highest Tax (as % of total tax revenue) in Dominican Republic?
Offer a terse response. 0.01. What is the difference between the highest and the second highest Tax (as % of total tax revenue) in Russian Federation?
Your response must be concise. 1.48. What is the difference between the highest and the second highest Tax (as % of total tax revenue) of Thailand?
Offer a very short reply. 0.02. What is the difference between the highest and the lowest Tax (as % of total tax revenue) in Cote d'Ivoire?
Your response must be concise. 7.69. What is the difference between the highest and the lowest Tax (as % of total tax revenue) of Dominican Republic?
Provide a succinct answer. 0.06. What is the difference between the highest and the lowest Tax (as % of total tax revenue) in Russian Federation?
Your response must be concise. 6.97. What is the difference between the highest and the lowest Tax (as % of total tax revenue) of Thailand?
Your answer should be compact. 0.31. 